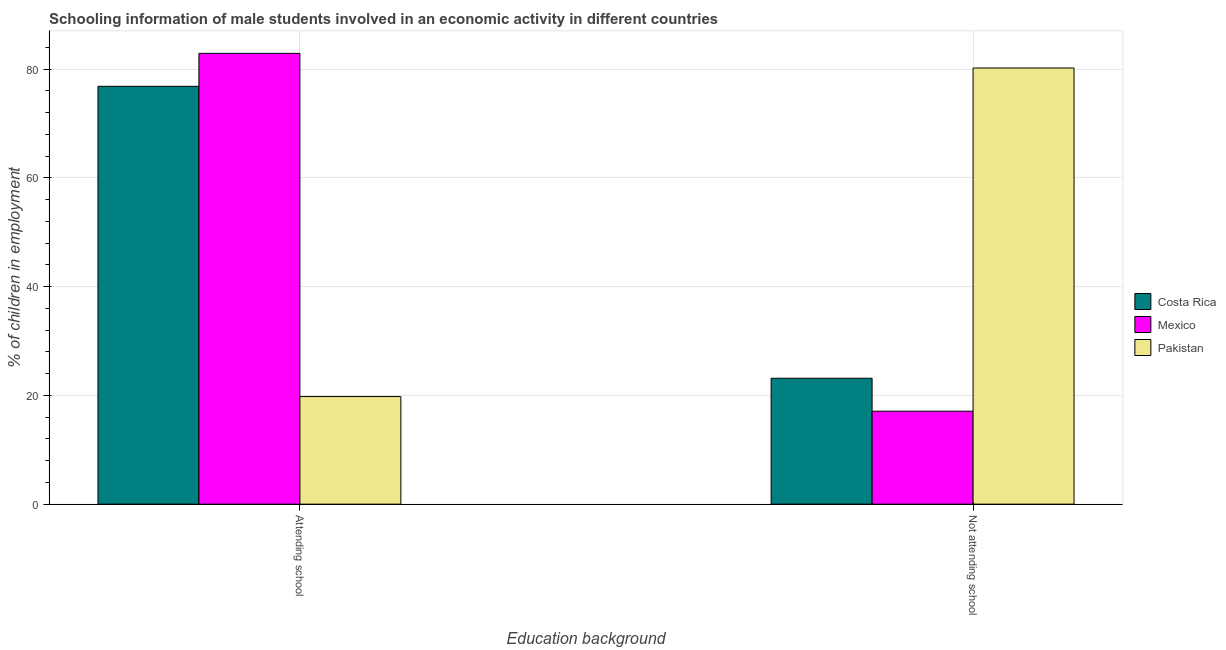How many different coloured bars are there?
Make the answer very short. 3. How many bars are there on the 1st tick from the right?
Your answer should be compact. 3. What is the label of the 2nd group of bars from the left?
Offer a very short reply. Not attending school. What is the percentage of employed males who are not attending school in Pakistan?
Offer a terse response. 80.21. Across all countries, what is the maximum percentage of employed males who are not attending school?
Your answer should be very brief. 80.21. Across all countries, what is the minimum percentage of employed males who are not attending school?
Offer a very short reply. 17.09. In which country was the percentage of employed males who are not attending school maximum?
Give a very brief answer. Pakistan. What is the total percentage of employed males who are attending school in the graph?
Keep it short and to the point. 179.54. What is the difference between the percentage of employed males who are not attending school in Mexico and that in Costa Rica?
Ensure brevity in your answer.  -6.06. What is the difference between the percentage of employed males who are attending school in Mexico and the percentage of employed males who are not attending school in Costa Rica?
Provide a short and direct response. 59.75. What is the average percentage of employed males who are not attending school per country?
Offer a terse response. 40.15. What is the difference between the percentage of employed males who are not attending school and percentage of employed males who are attending school in Mexico?
Provide a succinct answer. -65.81. What is the ratio of the percentage of employed males who are not attending school in Costa Rica to that in Mexico?
Provide a short and direct response. 1.35. Is the percentage of employed males who are attending school in Mexico less than that in Pakistan?
Make the answer very short. No. What does the 1st bar from the left in Attending school represents?
Offer a terse response. Costa Rica. What is the difference between two consecutive major ticks on the Y-axis?
Offer a terse response. 20. Does the graph contain grids?
Provide a short and direct response. Yes. How are the legend labels stacked?
Keep it short and to the point. Vertical. What is the title of the graph?
Your answer should be very brief. Schooling information of male students involved in an economic activity in different countries. Does "Nicaragua" appear as one of the legend labels in the graph?
Give a very brief answer. No. What is the label or title of the X-axis?
Make the answer very short. Education background. What is the label or title of the Y-axis?
Ensure brevity in your answer.  % of children in employment. What is the % of children in employment in Costa Rica in Attending school?
Offer a very short reply. 76.85. What is the % of children in employment of Mexico in Attending school?
Your answer should be compact. 82.91. What is the % of children in employment in Pakistan in Attending school?
Your response must be concise. 19.79. What is the % of children in employment in Costa Rica in Not attending school?
Give a very brief answer. 23.15. What is the % of children in employment of Mexico in Not attending school?
Provide a short and direct response. 17.09. What is the % of children in employment of Pakistan in Not attending school?
Offer a terse response. 80.21. Across all Education background, what is the maximum % of children in employment in Costa Rica?
Keep it short and to the point. 76.85. Across all Education background, what is the maximum % of children in employment of Mexico?
Your answer should be very brief. 82.91. Across all Education background, what is the maximum % of children in employment of Pakistan?
Offer a very short reply. 80.21. Across all Education background, what is the minimum % of children in employment in Costa Rica?
Your answer should be compact. 23.15. Across all Education background, what is the minimum % of children in employment of Mexico?
Keep it short and to the point. 17.09. Across all Education background, what is the minimum % of children in employment in Pakistan?
Provide a short and direct response. 19.79. What is the total % of children in employment in Costa Rica in the graph?
Offer a very short reply. 100. What is the total % of children in employment in Mexico in the graph?
Your answer should be very brief. 100. What is the difference between the % of children in employment in Costa Rica in Attending school and that in Not attending school?
Offer a terse response. 53.69. What is the difference between the % of children in employment in Mexico in Attending school and that in Not attending school?
Provide a short and direct response. 65.81. What is the difference between the % of children in employment in Pakistan in Attending school and that in Not attending school?
Give a very brief answer. -60.43. What is the difference between the % of children in employment of Costa Rica in Attending school and the % of children in employment of Mexico in Not attending school?
Your response must be concise. 59.75. What is the difference between the % of children in employment in Costa Rica in Attending school and the % of children in employment in Pakistan in Not attending school?
Give a very brief answer. -3.37. What is the difference between the % of children in employment in Mexico in Attending school and the % of children in employment in Pakistan in Not attending school?
Offer a very short reply. 2.69. What is the average % of children in employment in Costa Rica per Education background?
Provide a short and direct response. 50. What is the average % of children in employment of Mexico per Education background?
Your answer should be very brief. 50. What is the difference between the % of children in employment in Costa Rica and % of children in employment in Mexico in Attending school?
Keep it short and to the point. -6.06. What is the difference between the % of children in employment in Costa Rica and % of children in employment in Pakistan in Attending school?
Your answer should be compact. 57.06. What is the difference between the % of children in employment of Mexico and % of children in employment of Pakistan in Attending school?
Keep it short and to the point. 63.12. What is the difference between the % of children in employment in Costa Rica and % of children in employment in Mexico in Not attending school?
Provide a short and direct response. 6.06. What is the difference between the % of children in employment in Costa Rica and % of children in employment in Pakistan in Not attending school?
Offer a very short reply. -57.06. What is the difference between the % of children in employment of Mexico and % of children in employment of Pakistan in Not attending school?
Provide a succinct answer. -63.12. What is the ratio of the % of children in employment of Costa Rica in Attending school to that in Not attending school?
Your answer should be very brief. 3.32. What is the ratio of the % of children in employment in Mexico in Attending school to that in Not attending school?
Offer a very short reply. 4.85. What is the ratio of the % of children in employment of Pakistan in Attending school to that in Not attending school?
Provide a succinct answer. 0.25. What is the difference between the highest and the second highest % of children in employment of Costa Rica?
Make the answer very short. 53.69. What is the difference between the highest and the second highest % of children in employment in Mexico?
Make the answer very short. 65.81. What is the difference between the highest and the second highest % of children in employment in Pakistan?
Offer a very short reply. 60.43. What is the difference between the highest and the lowest % of children in employment of Costa Rica?
Offer a terse response. 53.69. What is the difference between the highest and the lowest % of children in employment in Mexico?
Offer a terse response. 65.81. What is the difference between the highest and the lowest % of children in employment in Pakistan?
Your answer should be very brief. 60.43. 